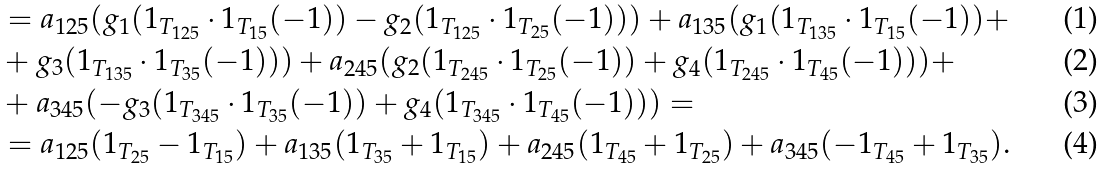<formula> <loc_0><loc_0><loc_500><loc_500>& = a _ { 1 2 5 } ( g _ { 1 } ( 1 _ { T _ { 1 2 5 } } \cdot 1 _ { T _ { 1 5 } } ( - 1 ) ) - g _ { 2 } ( 1 _ { T _ { 1 2 5 } } \cdot 1 _ { T _ { 2 5 } } ( - 1 ) ) ) + a _ { 1 3 5 } ( g _ { 1 } ( 1 _ { T _ { 1 3 5 } } \cdot 1 _ { T _ { 1 5 } } ( - 1 ) ) + \\ & + g _ { 3 } ( 1 _ { T _ { 1 3 5 } } \cdot 1 _ { T _ { 3 5 } } ( - 1 ) ) ) + a _ { 2 4 5 } ( g _ { 2 } ( 1 _ { T _ { 2 4 5 } } \cdot 1 _ { T _ { 2 5 } } ( - 1 ) ) + g _ { 4 } ( 1 _ { T _ { 2 4 5 } } \cdot 1 _ { T _ { 4 5 } } ( - 1 ) ) ) + \\ & + a _ { 3 4 5 } ( - g _ { 3 } ( 1 _ { T _ { 3 4 5 } } \cdot 1 _ { T _ { 3 5 } } ( - 1 ) ) + g _ { 4 } ( 1 _ { T _ { 3 4 5 } } \cdot 1 _ { T _ { 4 5 } } ( - 1 ) ) ) = \\ & = a _ { 1 2 5 } ( 1 _ { T _ { 2 5 } } - 1 _ { T _ { 1 5 } } ) + a _ { 1 3 5 } ( 1 _ { T _ { 3 5 } } + 1 _ { T _ { 1 5 } } ) + a _ { 2 4 5 } ( 1 _ { T _ { 4 5 } } + 1 _ { T _ { 2 5 } } ) + a _ { 3 4 5 } ( - 1 _ { T _ { 4 5 } } + 1 _ { T _ { 3 5 } } ) .</formula> 